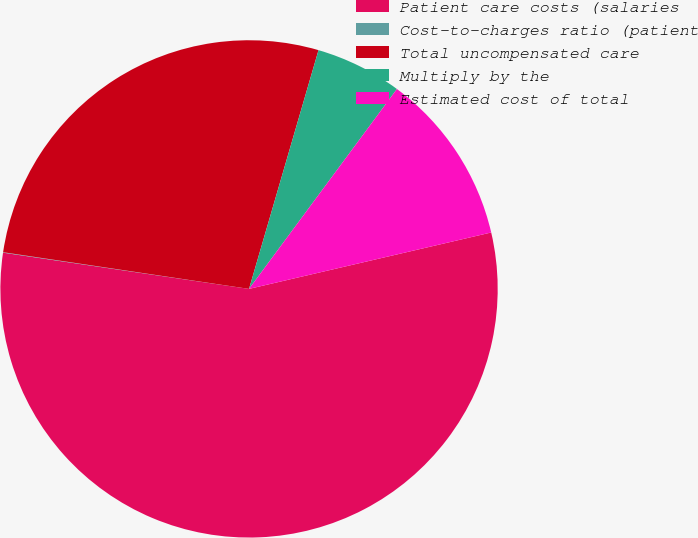Convert chart. <chart><loc_0><loc_0><loc_500><loc_500><pie_chart><fcel>Patient care costs (salaries<fcel>Cost-to-charges ratio (patient<fcel>Total uncompensated care<fcel>Multiply by the<fcel>Estimated cost of total<nl><fcel>55.97%<fcel>0.03%<fcel>27.15%<fcel>5.63%<fcel>11.22%<nl></chart> 